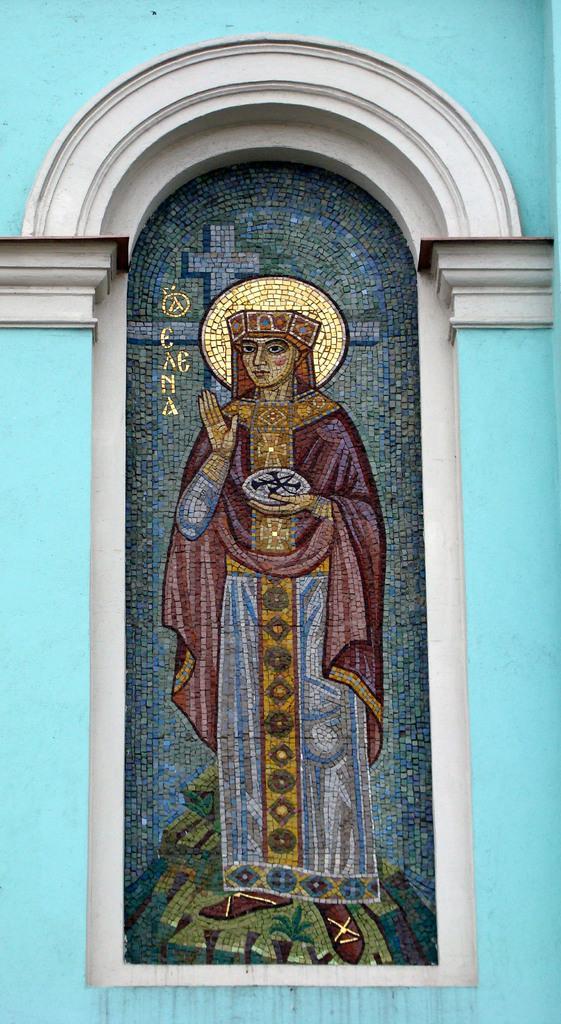How would you summarize this image in a sentence or two? This image consist of a wall and a window. On the glass, we can see can see a painting of a person along with the text. 